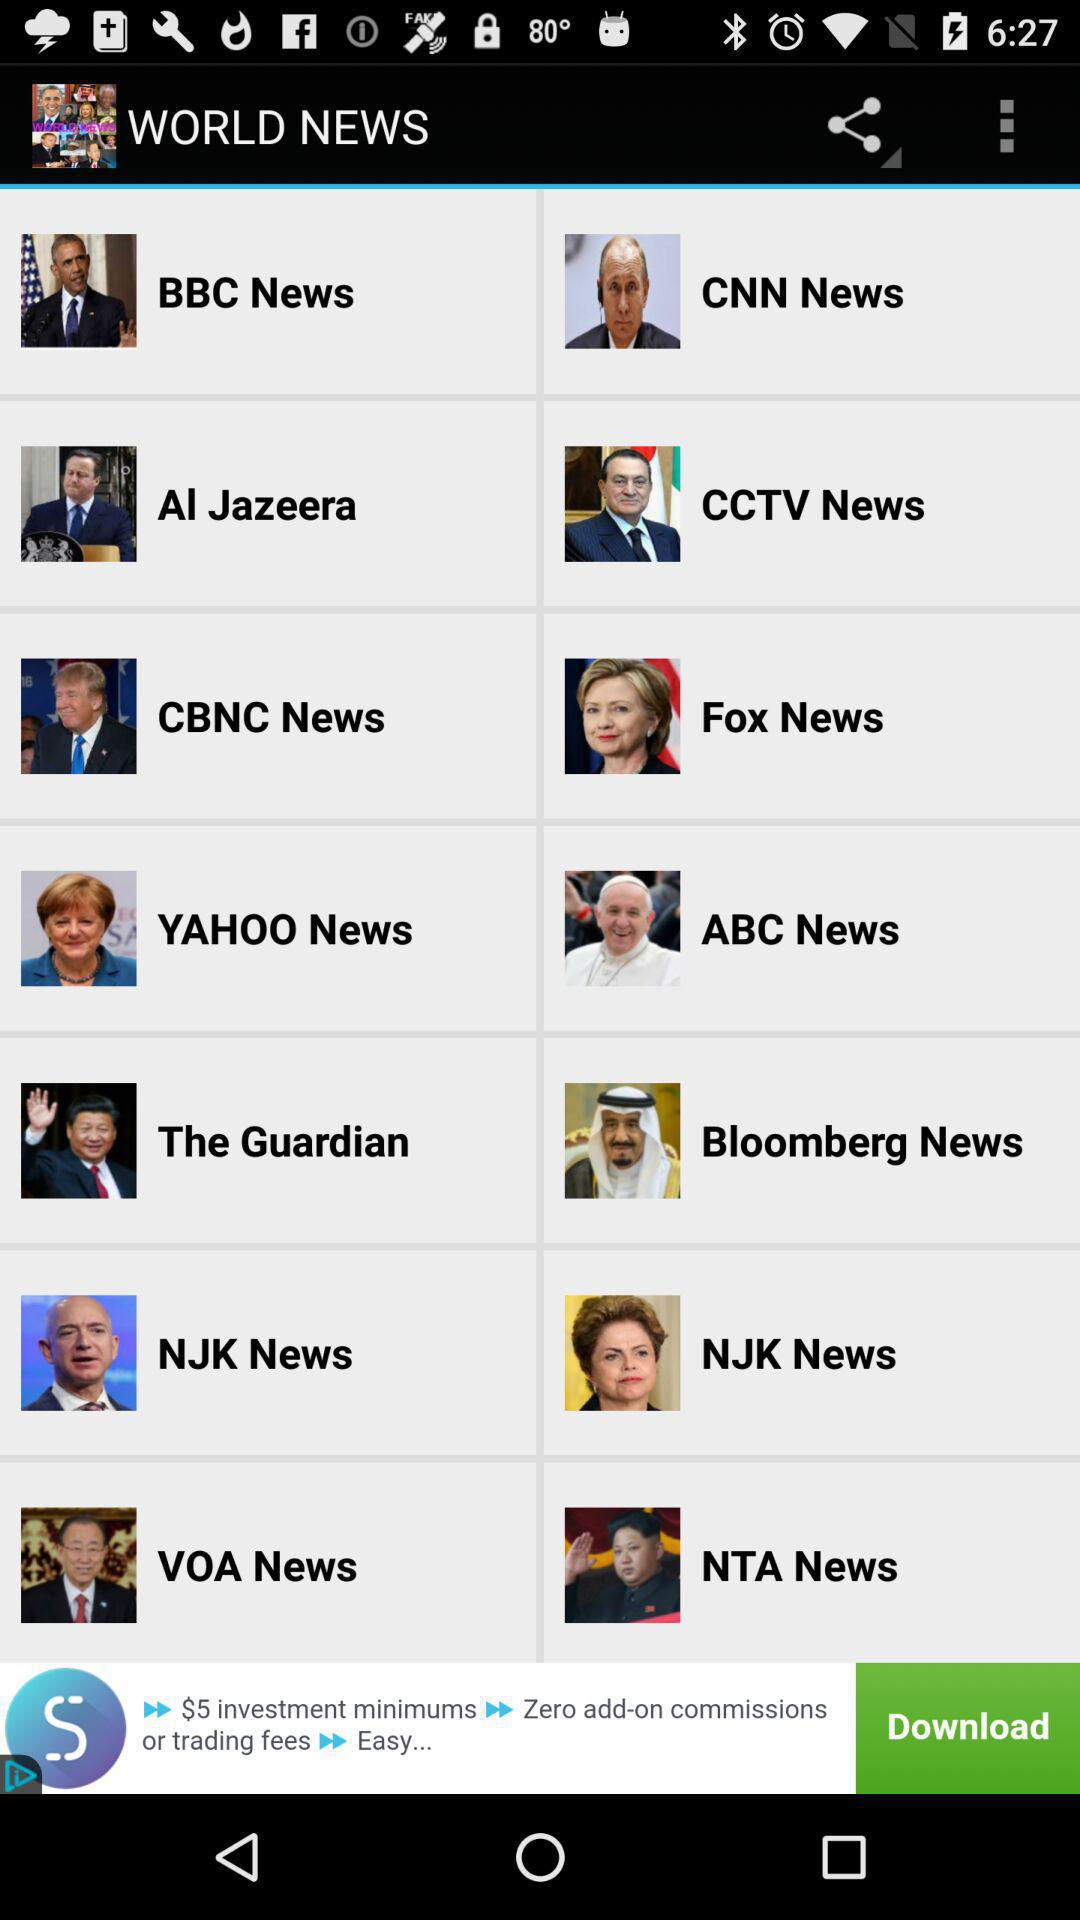What is the name of the application? The name of the application is "WORLD NEWS". 